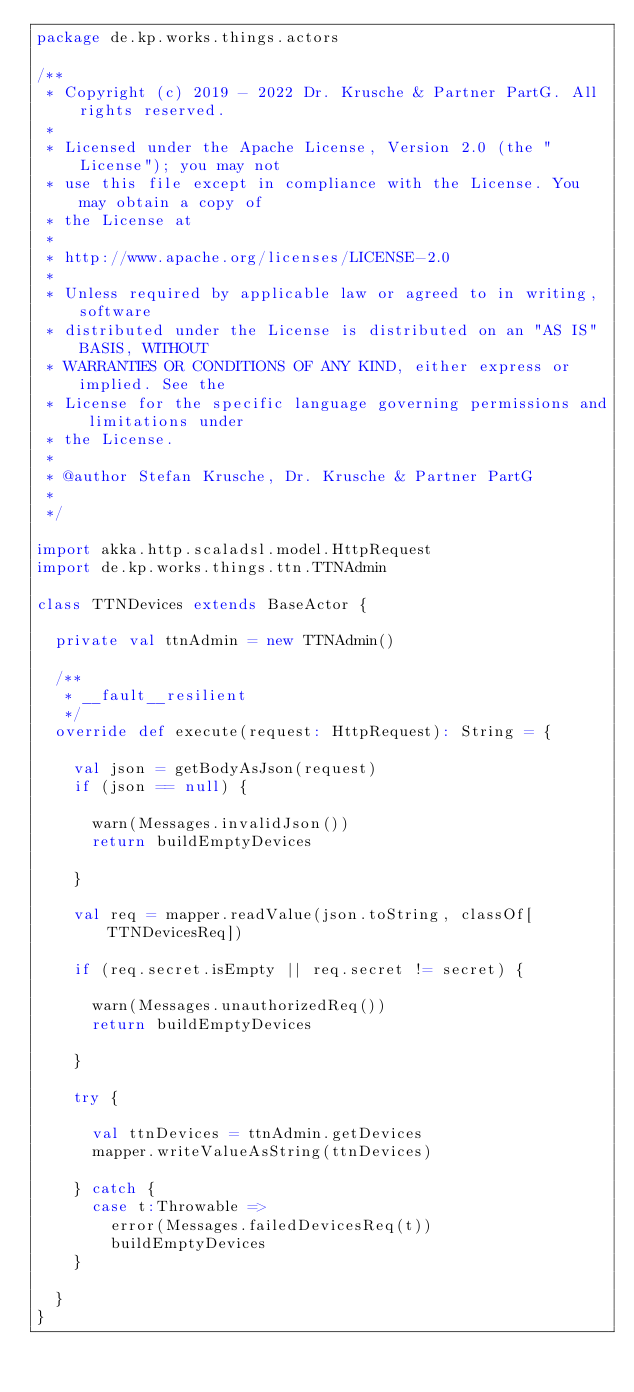<code> <loc_0><loc_0><loc_500><loc_500><_Scala_>package de.kp.works.things.actors

/**
 * Copyright (c) 2019 - 2022 Dr. Krusche & Partner PartG. All rights reserved.
 *
 * Licensed under the Apache License, Version 2.0 (the "License"); you may not
 * use this file except in compliance with the License. You may obtain a copy of
 * the License at
 *
 * http://www.apache.org/licenses/LICENSE-2.0
 *
 * Unless required by applicable law or agreed to in writing, software
 * distributed under the License is distributed on an "AS IS" BASIS, WITHOUT
 * WARRANTIES OR CONDITIONS OF ANY KIND, either express or implied. See the
 * License for the specific language governing permissions and limitations under
 * the License.
 *
 * @author Stefan Krusche, Dr. Krusche & Partner PartG
 *
 */

import akka.http.scaladsl.model.HttpRequest
import de.kp.works.things.ttn.TTNAdmin

class TTNDevices extends BaseActor {

  private val ttnAdmin = new TTNAdmin()

  /**
   * __fault__resilient
   */
  override def execute(request: HttpRequest): String = {

    val json = getBodyAsJson(request)
    if (json == null) {

      warn(Messages.invalidJson())
      return buildEmptyDevices

    }

    val req = mapper.readValue(json.toString, classOf[TTNDevicesReq])

    if (req.secret.isEmpty || req.secret != secret) {

      warn(Messages.unauthorizedReq())
      return buildEmptyDevices

    }

    try {

      val ttnDevices = ttnAdmin.getDevices
      mapper.writeValueAsString(ttnDevices)

    } catch {
      case t:Throwable =>
        error(Messages.failedDevicesReq(t))
        buildEmptyDevices
    }

  }
}
</code> 